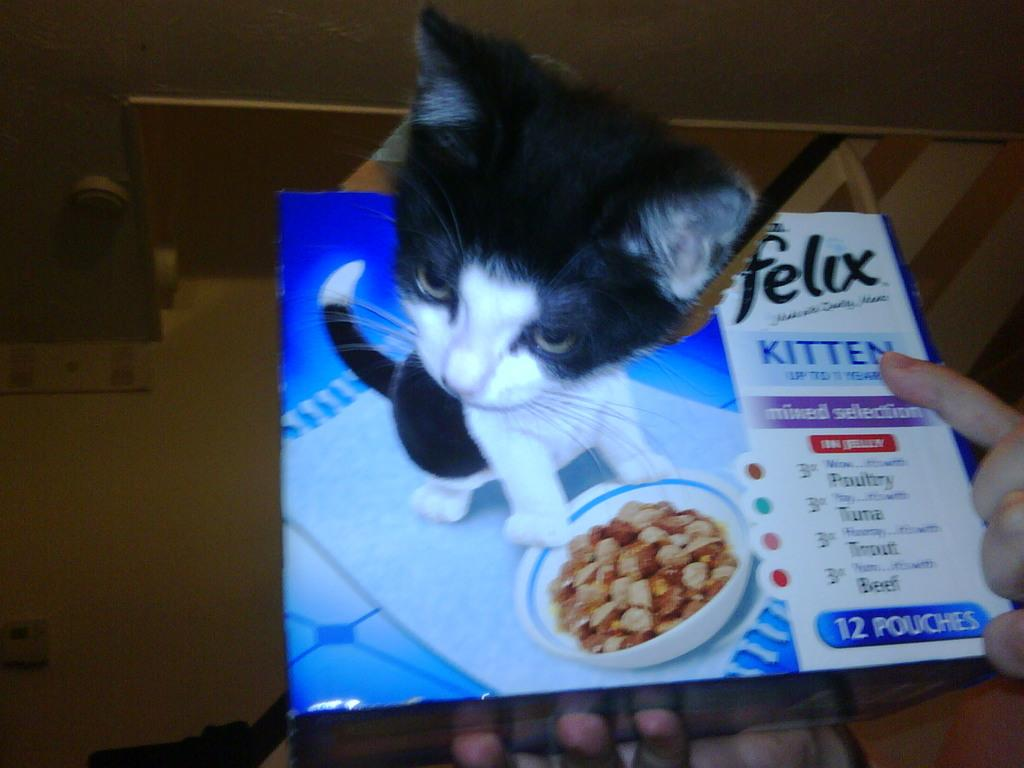What type of animal is in the image? There is a cat in the image. What is covering the cat in the image? There is a sheet in the image. Whose hands are visible in the image? Hands are visible in the image. How many spots can be seen on the cat's toes in the image? There are no spots visible on the cat's toes in the image, and the cat's toes are not mentioned in the provided facts. 